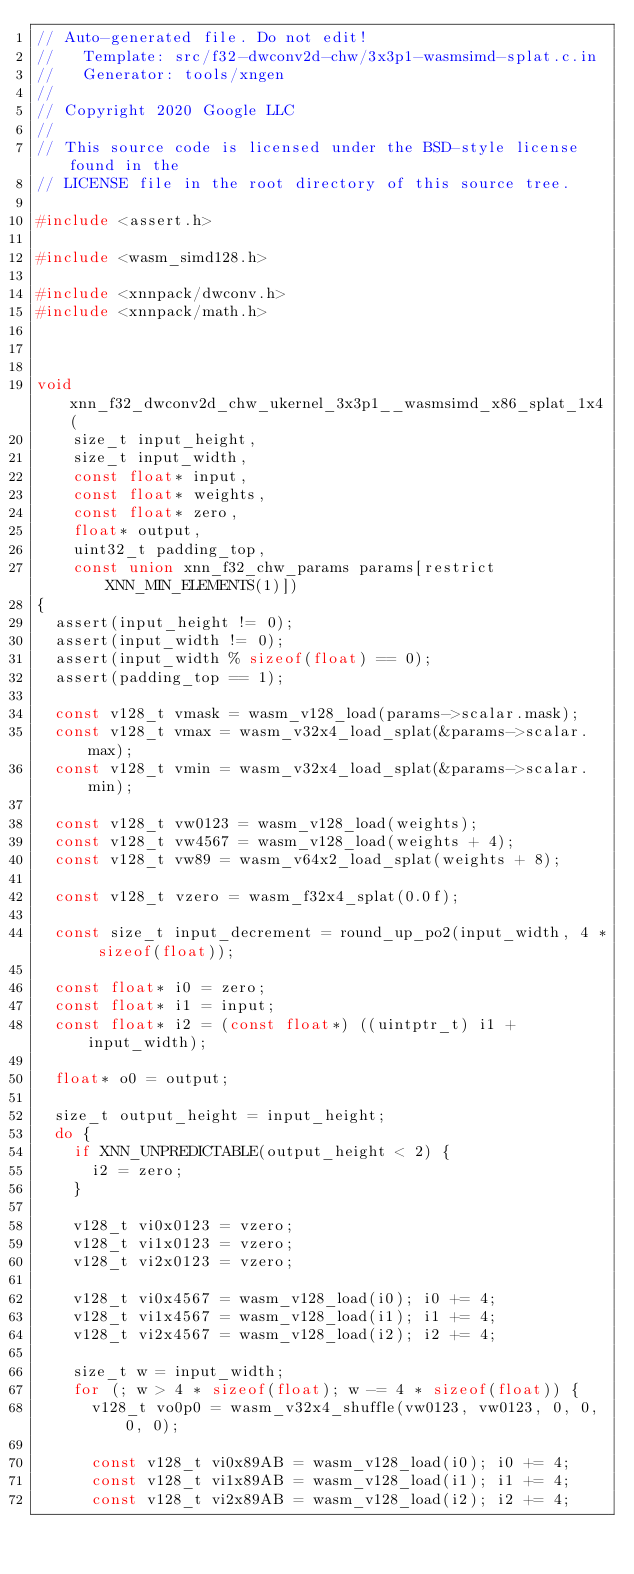Convert code to text. <code><loc_0><loc_0><loc_500><loc_500><_C_>// Auto-generated file. Do not edit!
//   Template: src/f32-dwconv2d-chw/3x3p1-wasmsimd-splat.c.in
//   Generator: tools/xngen
//
// Copyright 2020 Google LLC
//
// This source code is licensed under the BSD-style license found in the
// LICENSE file in the root directory of this source tree.

#include <assert.h>

#include <wasm_simd128.h>

#include <xnnpack/dwconv.h>
#include <xnnpack/math.h>



void xnn_f32_dwconv2d_chw_ukernel_3x3p1__wasmsimd_x86_splat_1x4(
    size_t input_height,
    size_t input_width,
    const float* input,
    const float* weights,
    const float* zero,
    float* output,
    uint32_t padding_top,
    const union xnn_f32_chw_params params[restrict XNN_MIN_ELEMENTS(1)])
{
  assert(input_height != 0);
  assert(input_width != 0);
  assert(input_width % sizeof(float) == 0);
  assert(padding_top == 1);

  const v128_t vmask = wasm_v128_load(params->scalar.mask);
  const v128_t vmax = wasm_v32x4_load_splat(&params->scalar.max);
  const v128_t vmin = wasm_v32x4_load_splat(&params->scalar.min);

  const v128_t vw0123 = wasm_v128_load(weights);
  const v128_t vw4567 = wasm_v128_load(weights + 4);
  const v128_t vw89 = wasm_v64x2_load_splat(weights + 8);

  const v128_t vzero = wasm_f32x4_splat(0.0f);

  const size_t input_decrement = round_up_po2(input_width, 4 * sizeof(float));

  const float* i0 = zero;
  const float* i1 = input;
  const float* i2 = (const float*) ((uintptr_t) i1 + input_width);

  float* o0 = output;

  size_t output_height = input_height;
  do {
    if XNN_UNPREDICTABLE(output_height < 2) {
      i2 = zero;
    }

    v128_t vi0x0123 = vzero;
    v128_t vi1x0123 = vzero;
    v128_t vi2x0123 = vzero;

    v128_t vi0x4567 = wasm_v128_load(i0); i0 += 4;
    v128_t vi1x4567 = wasm_v128_load(i1); i1 += 4;
    v128_t vi2x4567 = wasm_v128_load(i2); i2 += 4;

    size_t w = input_width;
    for (; w > 4 * sizeof(float); w -= 4 * sizeof(float)) {
      v128_t vo0p0 = wasm_v32x4_shuffle(vw0123, vw0123, 0, 0, 0, 0);

      const v128_t vi0x89AB = wasm_v128_load(i0); i0 += 4;
      const v128_t vi1x89AB = wasm_v128_load(i1); i1 += 4;
      const v128_t vi2x89AB = wasm_v128_load(i2); i2 += 4;
</code> 